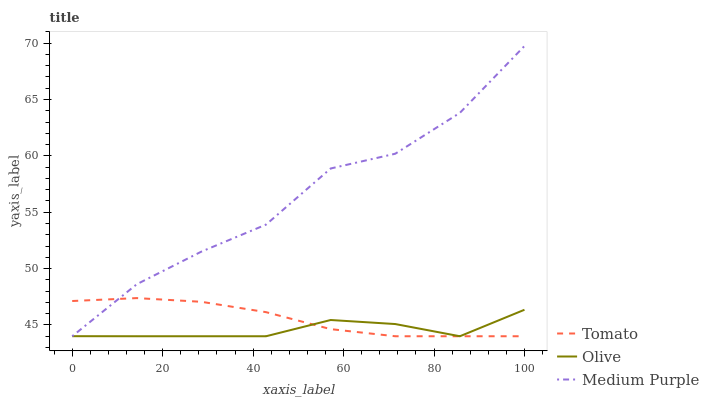Does Medium Purple have the minimum area under the curve?
Answer yes or no. No. Does Olive have the maximum area under the curve?
Answer yes or no. No. Is Olive the smoothest?
Answer yes or no. No. Is Olive the roughest?
Answer yes or no. No. Does Olive have the highest value?
Answer yes or no. No. 